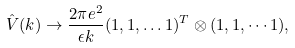Convert formula to latex. <formula><loc_0><loc_0><loc_500><loc_500>\hat { V } ( k ) \rightarrow \frac { 2 \pi e ^ { 2 } } { \epsilon k } ( 1 , 1 , \dots 1 ) ^ { T } \otimes ( 1 , 1 , \cdots 1 ) ,</formula> 